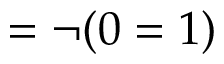Convert formula to latex. <formula><loc_0><loc_0><loc_500><loc_500>= \neg ( 0 = 1 )</formula> 